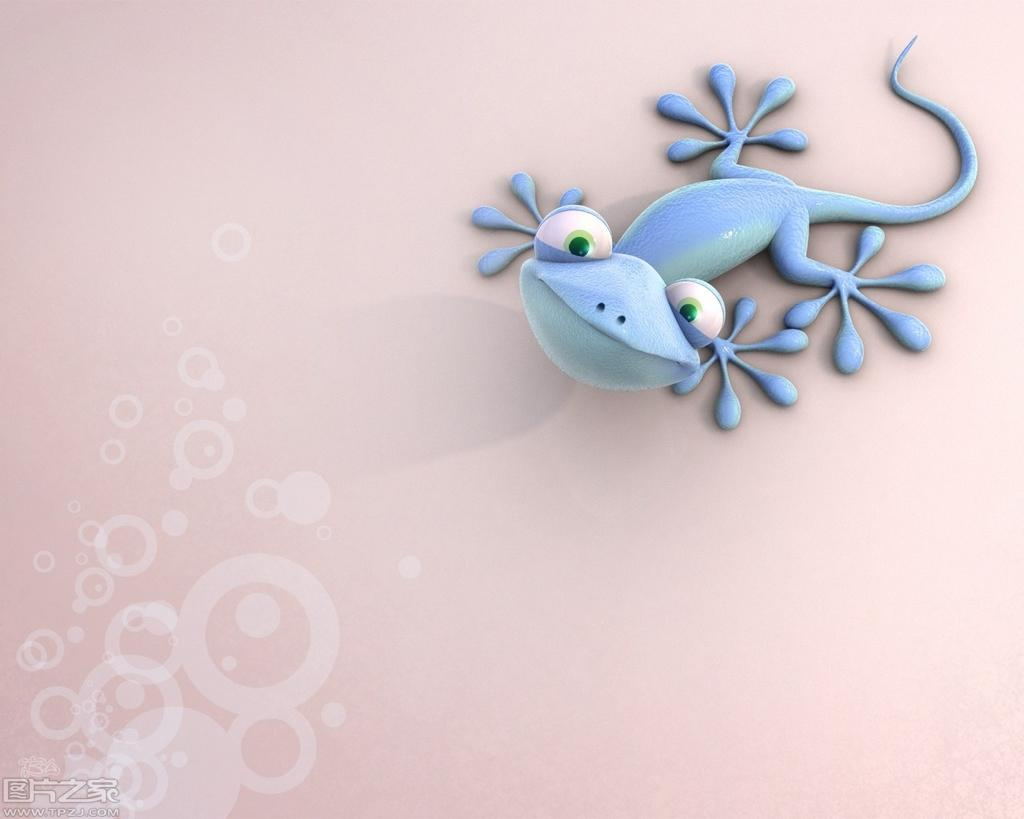What type of animal is present on the surface in the image? There is a lizard on the surface in the image. What is the nature of the image? The image is animated. Is there any additional information or branding present on the image? Yes, there is a watermark on the image. What type of coat is the lizard wearing in the image? The lizard is not wearing a coat in the image, as lizards do not wear clothing. 